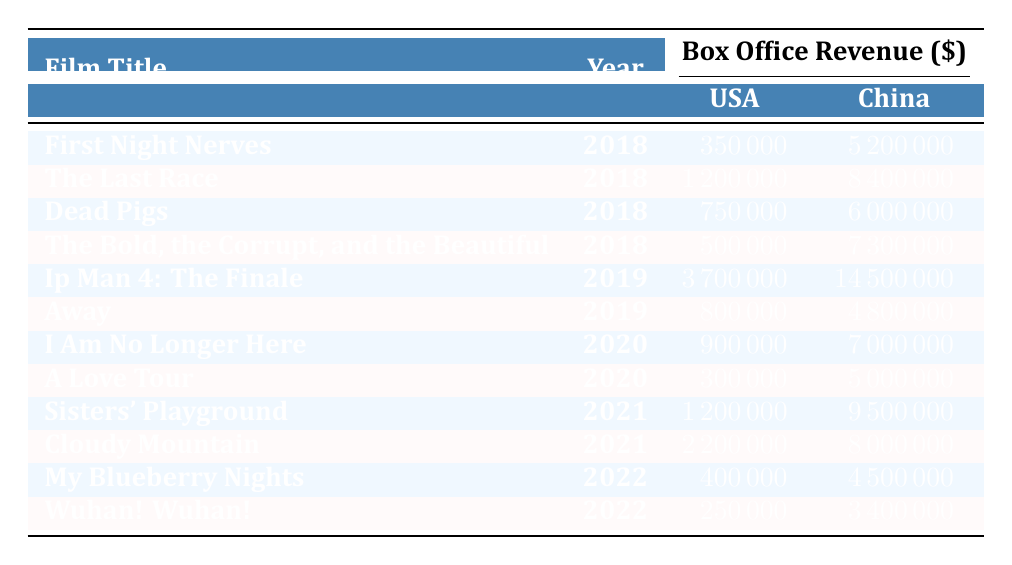What was the highest box office revenue in China for Vivian Wu’s films from 2018 to 2022? Looking at the "BoxOfficeRevenueChina" column, "Ip Man 4: The Finale" has the highest revenue at 14500000 in 2019.
Answer: 14500000 Which film had the lowest box office revenue in the USA? The film with the lowest "BoxOfficeRevenueUSA" is "Wuhan! Wuhan!" with a revenue of 250000 in 2022.
Answer: 250000 What is the sum of box office revenues in the USA for all films in 2018? Summing up the "BoxOfficeRevenueUSA" for 2018: 350000 + 1200000 + 750000 + 500000 =  2500000.
Answer: 2500000 Did "A Love Tour" perform better in the USA or China based on box office revenue? "A Love Tour" earned 300000 in the USA and 5000000 in China; since 5000000 is greater than 300000, it performed better in China.
Answer: Yes What was the average box office revenue in China for Vivian Wu's films over the five years? To find the average, we sum the China revenues: 5200000 + 8400000 + 6000000 + 7300000 + 14500000 + 4800000 + 7000000 + 5000000 + 9500000 + 8000000 + 4500000 + 3400000 =  74400000. There are 12 films, so the average is 74400000 / 12 = 6200000.
Answer: 6200000 Which year had the highest total sum of box office revenues in the USA? The yearly sums are: 2018: 2500000, 2019: 4500000, 2020: 1200000, 2021: 3400000, 2022: 650000. The highest is 4500000 in 2019.
Answer: 2019 How many films had box office revenues greater than 5 million in China? The films with "BoxOfficeRevenueChina" greater than 5000000 are "First Night Nerves," "The Last Race," "Dead Pigs," "The Bold, the Corrupt, and the Beautiful," "Ip Man 4: The Finale," "I Am No Longer Here," "Sisters' Playground," "Cloudy Mountain," with a total of 8 films.
Answer: 8 Was "Cloudy Mountain" released in the same year as "Wuhan! Wuhan!"? "Cloudy Mountain" was released in 2021, while "Wuhan! Wuhan!" was released in 2022. Therefore, they were not released in the same year.
Answer: No 